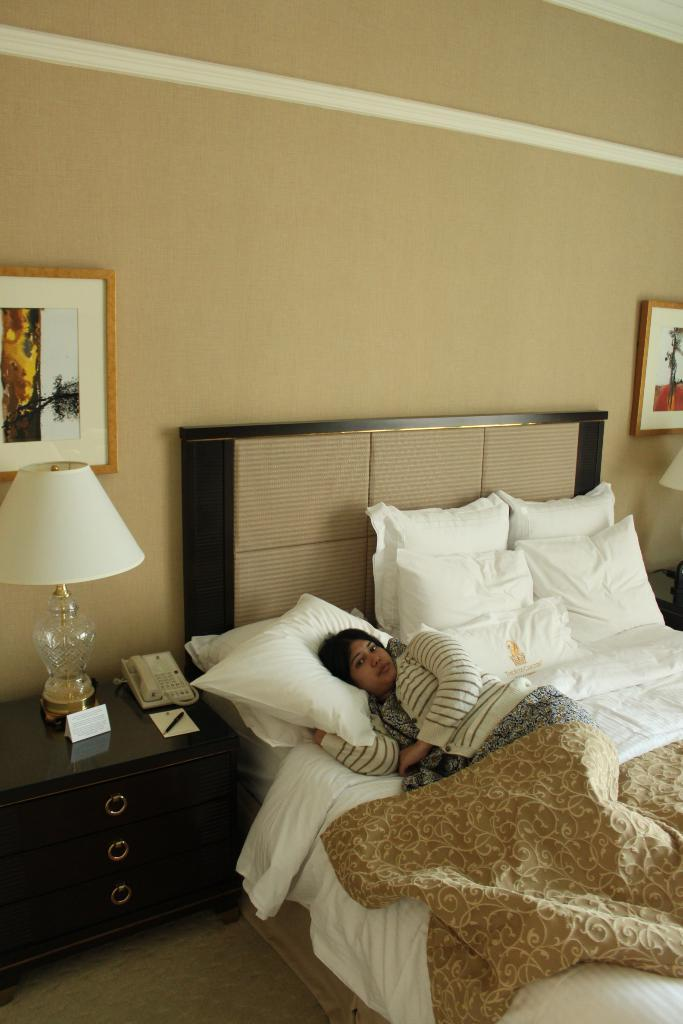What type of room is depicted in the image? The image is of a bedroom. What is the woman in the image doing? The woman is laying in the bed. What is covering the woman in the bed? There is a blanket on the bed. What is supporting the woman's head in the bed? There is a pillow on the bed. What is attached to the wall in the room? There is a frame attached to the wall. What is providing light in the room? There is a lamp in the room. What is used for storing items in the room? There is a cupboard in the room. What is used for communication in the room? There is a telephone in the room. How many boys are playing with a cent in the image? There are no boys or cents present in the image. What type of wish can be granted by the woman in the image? There is no mention of wishes or any magical elements in the image. 